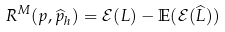<formula> <loc_0><loc_0><loc_500><loc_500>R ^ { M } ( p , \widehat { p } _ { h } ) = \mathcal { E } ( L ) - \mathbb { E } ( \mathcal { E } ( \widehat { L } ) )</formula> 